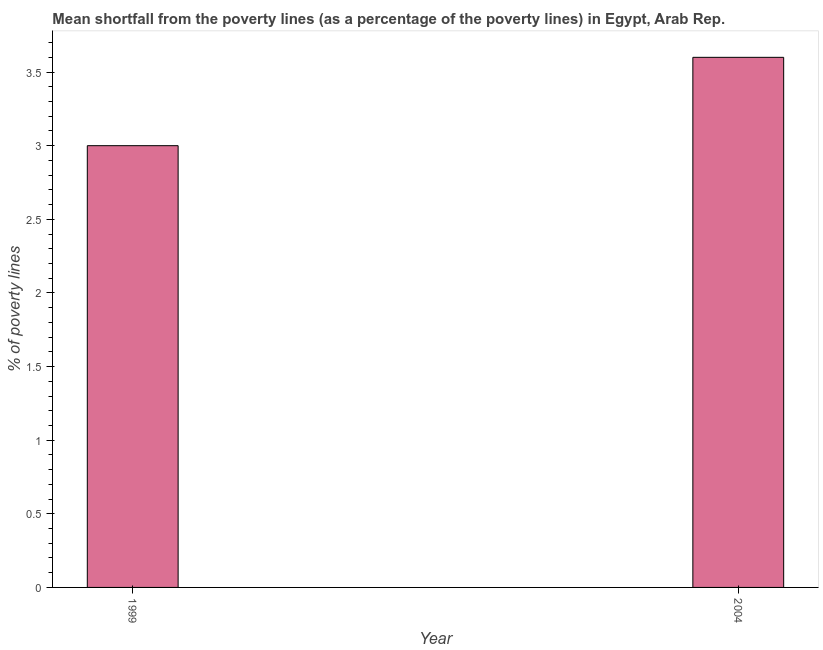What is the title of the graph?
Provide a short and direct response. Mean shortfall from the poverty lines (as a percentage of the poverty lines) in Egypt, Arab Rep. What is the label or title of the X-axis?
Keep it short and to the point. Year. What is the label or title of the Y-axis?
Keep it short and to the point. % of poverty lines. What is the poverty gap at national poverty lines in 2004?
Your answer should be very brief. 3.6. Across all years, what is the minimum poverty gap at national poverty lines?
Your response must be concise. 3. In which year was the poverty gap at national poverty lines minimum?
Provide a succinct answer. 1999. What is the sum of the poverty gap at national poverty lines?
Your response must be concise. 6.6. What is the average poverty gap at national poverty lines per year?
Offer a very short reply. 3.3. What is the median poverty gap at national poverty lines?
Your response must be concise. 3.3. Do a majority of the years between 1999 and 2004 (inclusive) have poverty gap at national poverty lines greater than 0.4 %?
Provide a short and direct response. Yes. What is the ratio of the poverty gap at national poverty lines in 1999 to that in 2004?
Make the answer very short. 0.83. In how many years, is the poverty gap at national poverty lines greater than the average poverty gap at national poverty lines taken over all years?
Your answer should be compact. 1. Are all the bars in the graph horizontal?
Provide a succinct answer. No. How many years are there in the graph?
Offer a very short reply. 2. Are the values on the major ticks of Y-axis written in scientific E-notation?
Ensure brevity in your answer.  No. What is the difference between the % of poverty lines in 1999 and 2004?
Your answer should be compact. -0.6. What is the ratio of the % of poverty lines in 1999 to that in 2004?
Offer a very short reply. 0.83. 